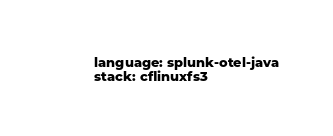<code> <loc_0><loc_0><loc_500><loc_500><_YAML_>language: splunk-otel-java
stack: cflinuxfs3</code> 